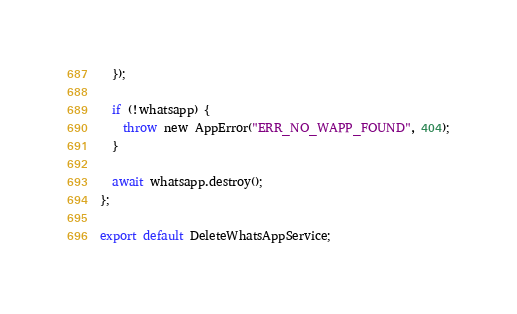<code> <loc_0><loc_0><loc_500><loc_500><_TypeScript_>  });

  if (!whatsapp) {
    throw new AppError("ERR_NO_WAPP_FOUND", 404);
  }

  await whatsapp.destroy();
};

export default DeleteWhatsAppService;
</code> 